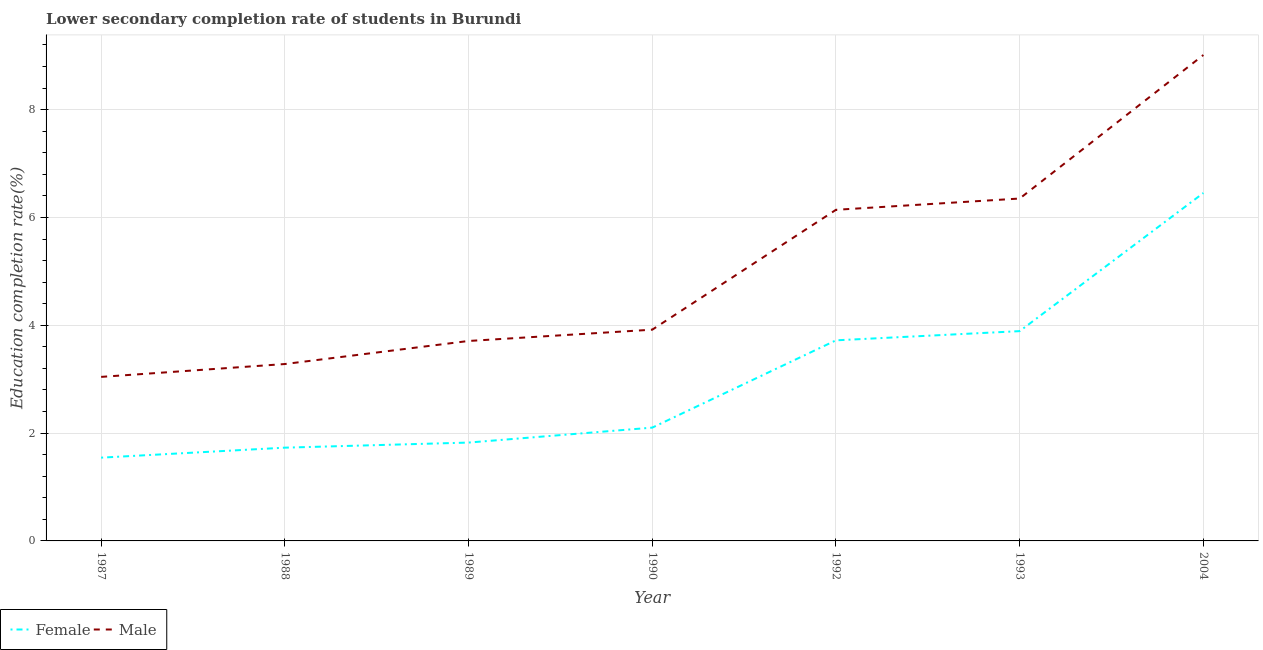Is the number of lines equal to the number of legend labels?
Make the answer very short. Yes. What is the education completion rate of male students in 1987?
Offer a terse response. 3.04. Across all years, what is the maximum education completion rate of female students?
Provide a succinct answer. 6.45. Across all years, what is the minimum education completion rate of male students?
Provide a short and direct response. 3.04. In which year was the education completion rate of female students maximum?
Provide a short and direct response. 2004. What is the total education completion rate of male students in the graph?
Your answer should be very brief. 35.46. What is the difference between the education completion rate of male students in 1987 and that in 2004?
Ensure brevity in your answer.  -5.97. What is the difference between the education completion rate of female students in 1987 and the education completion rate of male students in 2004?
Keep it short and to the point. -7.47. What is the average education completion rate of male students per year?
Your answer should be very brief. 5.07. In the year 1988, what is the difference between the education completion rate of female students and education completion rate of male students?
Provide a short and direct response. -1.55. What is the ratio of the education completion rate of male students in 1988 to that in 1992?
Offer a very short reply. 0.53. Is the difference between the education completion rate of male students in 1987 and 1993 greater than the difference between the education completion rate of female students in 1987 and 1993?
Give a very brief answer. No. What is the difference between the highest and the second highest education completion rate of male students?
Keep it short and to the point. 2.66. What is the difference between the highest and the lowest education completion rate of female students?
Your answer should be compact. 4.91. In how many years, is the education completion rate of male students greater than the average education completion rate of male students taken over all years?
Offer a terse response. 3. Is the sum of the education completion rate of female students in 1987 and 1992 greater than the maximum education completion rate of male students across all years?
Give a very brief answer. No. Is the education completion rate of male students strictly greater than the education completion rate of female students over the years?
Your answer should be compact. Yes. Is the education completion rate of male students strictly less than the education completion rate of female students over the years?
Offer a very short reply. No. How many lines are there?
Your answer should be compact. 2. How many years are there in the graph?
Provide a short and direct response. 7. Where does the legend appear in the graph?
Provide a short and direct response. Bottom left. How many legend labels are there?
Give a very brief answer. 2. How are the legend labels stacked?
Your answer should be compact. Horizontal. What is the title of the graph?
Give a very brief answer. Lower secondary completion rate of students in Burundi. What is the label or title of the Y-axis?
Provide a succinct answer. Education completion rate(%). What is the Education completion rate(%) in Female in 1987?
Ensure brevity in your answer.  1.54. What is the Education completion rate(%) in Male in 1987?
Offer a terse response. 3.04. What is the Education completion rate(%) of Female in 1988?
Keep it short and to the point. 1.73. What is the Education completion rate(%) in Male in 1988?
Your answer should be compact. 3.28. What is the Education completion rate(%) of Female in 1989?
Your answer should be very brief. 1.82. What is the Education completion rate(%) in Male in 1989?
Offer a very short reply. 3.71. What is the Education completion rate(%) of Female in 1990?
Keep it short and to the point. 2.1. What is the Education completion rate(%) in Male in 1990?
Provide a succinct answer. 3.92. What is the Education completion rate(%) of Female in 1992?
Provide a succinct answer. 3.72. What is the Education completion rate(%) in Male in 1992?
Keep it short and to the point. 6.14. What is the Education completion rate(%) of Female in 1993?
Give a very brief answer. 3.89. What is the Education completion rate(%) of Male in 1993?
Offer a very short reply. 6.35. What is the Education completion rate(%) in Female in 2004?
Offer a very short reply. 6.45. What is the Education completion rate(%) in Male in 2004?
Ensure brevity in your answer.  9.01. Across all years, what is the maximum Education completion rate(%) of Female?
Your answer should be compact. 6.45. Across all years, what is the maximum Education completion rate(%) of Male?
Keep it short and to the point. 9.01. Across all years, what is the minimum Education completion rate(%) in Female?
Provide a succinct answer. 1.54. Across all years, what is the minimum Education completion rate(%) in Male?
Make the answer very short. 3.04. What is the total Education completion rate(%) of Female in the graph?
Your answer should be very brief. 21.27. What is the total Education completion rate(%) of Male in the graph?
Make the answer very short. 35.46. What is the difference between the Education completion rate(%) of Female in 1987 and that in 1988?
Your answer should be compact. -0.19. What is the difference between the Education completion rate(%) of Male in 1987 and that in 1988?
Provide a succinct answer. -0.24. What is the difference between the Education completion rate(%) of Female in 1987 and that in 1989?
Ensure brevity in your answer.  -0.28. What is the difference between the Education completion rate(%) of Male in 1987 and that in 1989?
Offer a terse response. -0.67. What is the difference between the Education completion rate(%) in Female in 1987 and that in 1990?
Offer a very short reply. -0.56. What is the difference between the Education completion rate(%) of Male in 1987 and that in 1990?
Give a very brief answer. -0.88. What is the difference between the Education completion rate(%) in Female in 1987 and that in 1992?
Make the answer very short. -2.18. What is the difference between the Education completion rate(%) of Male in 1987 and that in 1992?
Your answer should be very brief. -3.1. What is the difference between the Education completion rate(%) of Female in 1987 and that in 1993?
Offer a terse response. -2.35. What is the difference between the Education completion rate(%) in Male in 1987 and that in 1993?
Give a very brief answer. -3.31. What is the difference between the Education completion rate(%) of Female in 1987 and that in 2004?
Provide a succinct answer. -4.91. What is the difference between the Education completion rate(%) in Male in 1987 and that in 2004?
Provide a succinct answer. -5.97. What is the difference between the Education completion rate(%) of Female in 1988 and that in 1989?
Provide a succinct answer. -0.09. What is the difference between the Education completion rate(%) of Male in 1988 and that in 1989?
Ensure brevity in your answer.  -0.43. What is the difference between the Education completion rate(%) of Female in 1988 and that in 1990?
Your answer should be very brief. -0.37. What is the difference between the Education completion rate(%) of Male in 1988 and that in 1990?
Make the answer very short. -0.64. What is the difference between the Education completion rate(%) of Female in 1988 and that in 1992?
Your answer should be very brief. -1.99. What is the difference between the Education completion rate(%) in Male in 1988 and that in 1992?
Give a very brief answer. -2.86. What is the difference between the Education completion rate(%) in Female in 1988 and that in 1993?
Offer a very short reply. -2.16. What is the difference between the Education completion rate(%) of Male in 1988 and that in 1993?
Provide a short and direct response. -3.07. What is the difference between the Education completion rate(%) in Female in 1988 and that in 2004?
Give a very brief answer. -4.72. What is the difference between the Education completion rate(%) of Male in 1988 and that in 2004?
Keep it short and to the point. -5.73. What is the difference between the Education completion rate(%) of Female in 1989 and that in 1990?
Provide a succinct answer. -0.28. What is the difference between the Education completion rate(%) in Male in 1989 and that in 1990?
Keep it short and to the point. -0.21. What is the difference between the Education completion rate(%) of Female in 1989 and that in 1992?
Make the answer very short. -1.9. What is the difference between the Education completion rate(%) in Male in 1989 and that in 1992?
Provide a short and direct response. -2.43. What is the difference between the Education completion rate(%) of Female in 1989 and that in 1993?
Give a very brief answer. -2.07. What is the difference between the Education completion rate(%) in Male in 1989 and that in 1993?
Give a very brief answer. -2.64. What is the difference between the Education completion rate(%) in Female in 1989 and that in 2004?
Your answer should be compact. -4.63. What is the difference between the Education completion rate(%) of Male in 1989 and that in 2004?
Keep it short and to the point. -5.3. What is the difference between the Education completion rate(%) of Female in 1990 and that in 1992?
Ensure brevity in your answer.  -1.62. What is the difference between the Education completion rate(%) of Male in 1990 and that in 1992?
Ensure brevity in your answer.  -2.22. What is the difference between the Education completion rate(%) of Female in 1990 and that in 1993?
Your answer should be compact. -1.79. What is the difference between the Education completion rate(%) of Male in 1990 and that in 1993?
Ensure brevity in your answer.  -2.43. What is the difference between the Education completion rate(%) in Female in 1990 and that in 2004?
Make the answer very short. -4.35. What is the difference between the Education completion rate(%) in Male in 1990 and that in 2004?
Give a very brief answer. -5.1. What is the difference between the Education completion rate(%) in Female in 1992 and that in 1993?
Your answer should be compact. -0.17. What is the difference between the Education completion rate(%) of Male in 1992 and that in 1993?
Your answer should be compact. -0.21. What is the difference between the Education completion rate(%) in Female in 1992 and that in 2004?
Provide a short and direct response. -2.73. What is the difference between the Education completion rate(%) in Male in 1992 and that in 2004?
Ensure brevity in your answer.  -2.87. What is the difference between the Education completion rate(%) in Female in 1993 and that in 2004?
Offer a terse response. -2.56. What is the difference between the Education completion rate(%) in Male in 1993 and that in 2004?
Make the answer very short. -2.66. What is the difference between the Education completion rate(%) in Female in 1987 and the Education completion rate(%) in Male in 1988?
Give a very brief answer. -1.74. What is the difference between the Education completion rate(%) of Female in 1987 and the Education completion rate(%) of Male in 1989?
Provide a succinct answer. -2.16. What is the difference between the Education completion rate(%) in Female in 1987 and the Education completion rate(%) in Male in 1990?
Give a very brief answer. -2.37. What is the difference between the Education completion rate(%) of Female in 1987 and the Education completion rate(%) of Male in 1992?
Your answer should be compact. -4.6. What is the difference between the Education completion rate(%) in Female in 1987 and the Education completion rate(%) in Male in 1993?
Make the answer very short. -4.81. What is the difference between the Education completion rate(%) of Female in 1987 and the Education completion rate(%) of Male in 2004?
Ensure brevity in your answer.  -7.47. What is the difference between the Education completion rate(%) in Female in 1988 and the Education completion rate(%) in Male in 1989?
Offer a terse response. -1.98. What is the difference between the Education completion rate(%) of Female in 1988 and the Education completion rate(%) of Male in 1990?
Your answer should be very brief. -2.19. What is the difference between the Education completion rate(%) in Female in 1988 and the Education completion rate(%) in Male in 1992?
Your answer should be compact. -4.41. What is the difference between the Education completion rate(%) of Female in 1988 and the Education completion rate(%) of Male in 1993?
Give a very brief answer. -4.62. What is the difference between the Education completion rate(%) of Female in 1988 and the Education completion rate(%) of Male in 2004?
Give a very brief answer. -7.28. What is the difference between the Education completion rate(%) of Female in 1989 and the Education completion rate(%) of Male in 1990?
Provide a succinct answer. -2.09. What is the difference between the Education completion rate(%) of Female in 1989 and the Education completion rate(%) of Male in 1992?
Offer a terse response. -4.32. What is the difference between the Education completion rate(%) of Female in 1989 and the Education completion rate(%) of Male in 1993?
Ensure brevity in your answer.  -4.53. What is the difference between the Education completion rate(%) of Female in 1989 and the Education completion rate(%) of Male in 2004?
Provide a short and direct response. -7.19. What is the difference between the Education completion rate(%) in Female in 1990 and the Education completion rate(%) in Male in 1992?
Your response must be concise. -4.04. What is the difference between the Education completion rate(%) of Female in 1990 and the Education completion rate(%) of Male in 1993?
Ensure brevity in your answer.  -4.25. What is the difference between the Education completion rate(%) of Female in 1990 and the Education completion rate(%) of Male in 2004?
Provide a short and direct response. -6.91. What is the difference between the Education completion rate(%) in Female in 1992 and the Education completion rate(%) in Male in 1993?
Keep it short and to the point. -2.63. What is the difference between the Education completion rate(%) of Female in 1992 and the Education completion rate(%) of Male in 2004?
Your answer should be compact. -5.29. What is the difference between the Education completion rate(%) in Female in 1993 and the Education completion rate(%) in Male in 2004?
Offer a terse response. -5.12. What is the average Education completion rate(%) of Female per year?
Ensure brevity in your answer.  3.04. What is the average Education completion rate(%) in Male per year?
Make the answer very short. 5.07. In the year 1987, what is the difference between the Education completion rate(%) in Female and Education completion rate(%) in Male?
Ensure brevity in your answer.  -1.5. In the year 1988, what is the difference between the Education completion rate(%) of Female and Education completion rate(%) of Male?
Keep it short and to the point. -1.55. In the year 1989, what is the difference between the Education completion rate(%) of Female and Education completion rate(%) of Male?
Provide a short and direct response. -1.88. In the year 1990, what is the difference between the Education completion rate(%) in Female and Education completion rate(%) in Male?
Provide a succinct answer. -1.82. In the year 1992, what is the difference between the Education completion rate(%) of Female and Education completion rate(%) of Male?
Provide a succinct answer. -2.42. In the year 1993, what is the difference between the Education completion rate(%) in Female and Education completion rate(%) in Male?
Your answer should be very brief. -2.46. In the year 2004, what is the difference between the Education completion rate(%) of Female and Education completion rate(%) of Male?
Provide a succinct answer. -2.56. What is the ratio of the Education completion rate(%) in Female in 1987 to that in 1988?
Keep it short and to the point. 0.89. What is the ratio of the Education completion rate(%) in Male in 1987 to that in 1988?
Your response must be concise. 0.93. What is the ratio of the Education completion rate(%) of Female in 1987 to that in 1989?
Your answer should be compact. 0.85. What is the ratio of the Education completion rate(%) in Male in 1987 to that in 1989?
Your answer should be very brief. 0.82. What is the ratio of the Education completion rate(%) in Female in 1987 to that in 1990?
Offer a very short reply. 0.73. What is the ratio of the Education completion rate(%) in Male in 1987 to that in 1990?
Offer a very short reply. 0.78. What is the ratio of the Education completion rate(%) in Female in 1987 to that in 1992?
Offer a terse response. 0.42. What is the ratio of the Education completion rate(%) of Male in 1987 to that in 1992?
Offer a terse response. 0.5. What is the ratio of the Education completion rate(%) in Female in 1987 to that in 1993?
Give a very brief answer. 0.4. What is the ratio of the Education completion rate(%) of Male in 1987 to that in 1993?
Your answer should be very brief. 0.48. What is the ratio of the Education completion rate(%) of Female in 1987 to that in 2004?
Provide a succinct answer. 0.24. What is the ratio of the Education completion rate(%) of Male in 1987 to that in 2004?
Ensure brevity in your answer.  0.34. What is the ratio of the Education completion rate(%) in Female in 1988 to that in 1989?
Provide a short and direct response. 0.95. What is the ratio of the Education completion rate(%) of Male in 1988 to that in 1989?
Provide a short and direct response. 0.88. What is the ratio of the Education completion rate(%) in Female in 1988 to that in 1990?
Provide a succinct answer. 0.82. What is the ratio of the Education completion rate(%) in Male in 1988 to that in 1990?
Your response must be concise. 0.84. What is the ratio of the Education completion rate(%) in Female in 1988 to that in 1992?
Your response must be concise. 0.46. What is the ratio of the Education completion rate(%) of Male in 1988 to that in 1992?
Provide a succinct answer. 0.53. What is the ratio of the Education completion rate(%) in Female in 1988 to that in 1993?
Your response must be concise. 0.44. What is the ratio of the Education completion rate(%) in Male in 1988 to that in 1993?
Your response must be concise. 0.52. What is the ratio of the Education completion rate(%) of Female in 1988 to that in 2004?
Provide a succinct answer. 0.27. What is the ratio of the Education completion rate(%) in Male in 1988 to that in 2004?
Provide a short and direct response. 0.36. What is the ratio of the Education completion rate(%) of Female in 1989 to that in 1990?
Offer a terse response. 0.87. What is the ratio of the Education completion rate(%) in Male in 1989 to that in 1990?
Offer a terse response. 0.95. What is the ratio of the Education completion rate(%) in Female in 1989 to that in 1992?
Offer a very short reply. 0.49. What is the ratio of the Education completion rate(%) in Male in 1989 to that in 1992?
Ensure brevity in your answer.  0.6. What is the ratio of the Education completion rate(%) of Female in 1989 to that in 1993?
Provide a succinct answer. 0.47. What is the ratio of the Education completion rate(%) in Male in 1989 to that in 1993?
Your answer should be compact. 0.58. What is the ratio of the Education completion rate(%) of Female in 1989 to that in 2004?
Your answer should be very brief. 0.28. What is the ratio of the Education completion rate(%) of Male in 1989 to that in 2004?
Offer a terse response. 0.41. What is the ratio of the Education completion rate(%) of Female in 1990 to that in 1992?
Provide a short and direct response. 0.56. What is the ratio of the Education completion rate(%) of Male in 1990 to that in 1992?
Make the answer very short. 0.64. What is the ratio of the Education completion rate(%) of Female in 1990 to that in 1993?
Ensure brevity in your answer.  0.54. What is the ratio of the Education completion rate(%) of Male in 1990 to that in 1993?
Your answer should be compact. 0.62. What is the ratio of the Education completion rate(%) of Female in 1990 to that in 2004?
Ensure brevity in your answer.  0.33. What is the ratio of the Education completion rate(%) of Male in 1990 to that in 2004?
Provide a short and direct response. 0.43. What is the ratio of the Education completion rate(%) in Female in 1992 to that in 1993?
Keep it short and to the point. 0.96. What is the ratio of the Education completion rate(%) of Male in 1992 to that in 1993?
Offer a terse response. 0.97. What is the ratio of the Education completion rate(%) in Female in 1992 to that in 2004?
Your answer should be very brief. 0.58. What is the ratio of the Education completion rate(%) of Male in 1992 to that in 2004?
Keep it short and to the point. 0.68. What is the ratio of the Education completion rate(%) in Female in 1993 to that in 2004?
Your answer should be very brief. 0.6. What is the ratio of the Education completion rate(%) of Male in 1993 to that in 2004?
Your answer should be compact. 0.7. What is the difference between the highest and the second highest Education completion rate(%) of Female?
Provide a short and direct response. 2.56. What is the difference between the highest and the second highest Education completion rate(%) in Male?
Give a very brief answer. 2.66. What is the difference between the highest and the lowest Education completion rate(%) in Female?
Give a very brief answer. 4.91. What is the difference between the highest and the lowest Education completion rate(%) of Male?
Give a very brief answer. 5.97. 